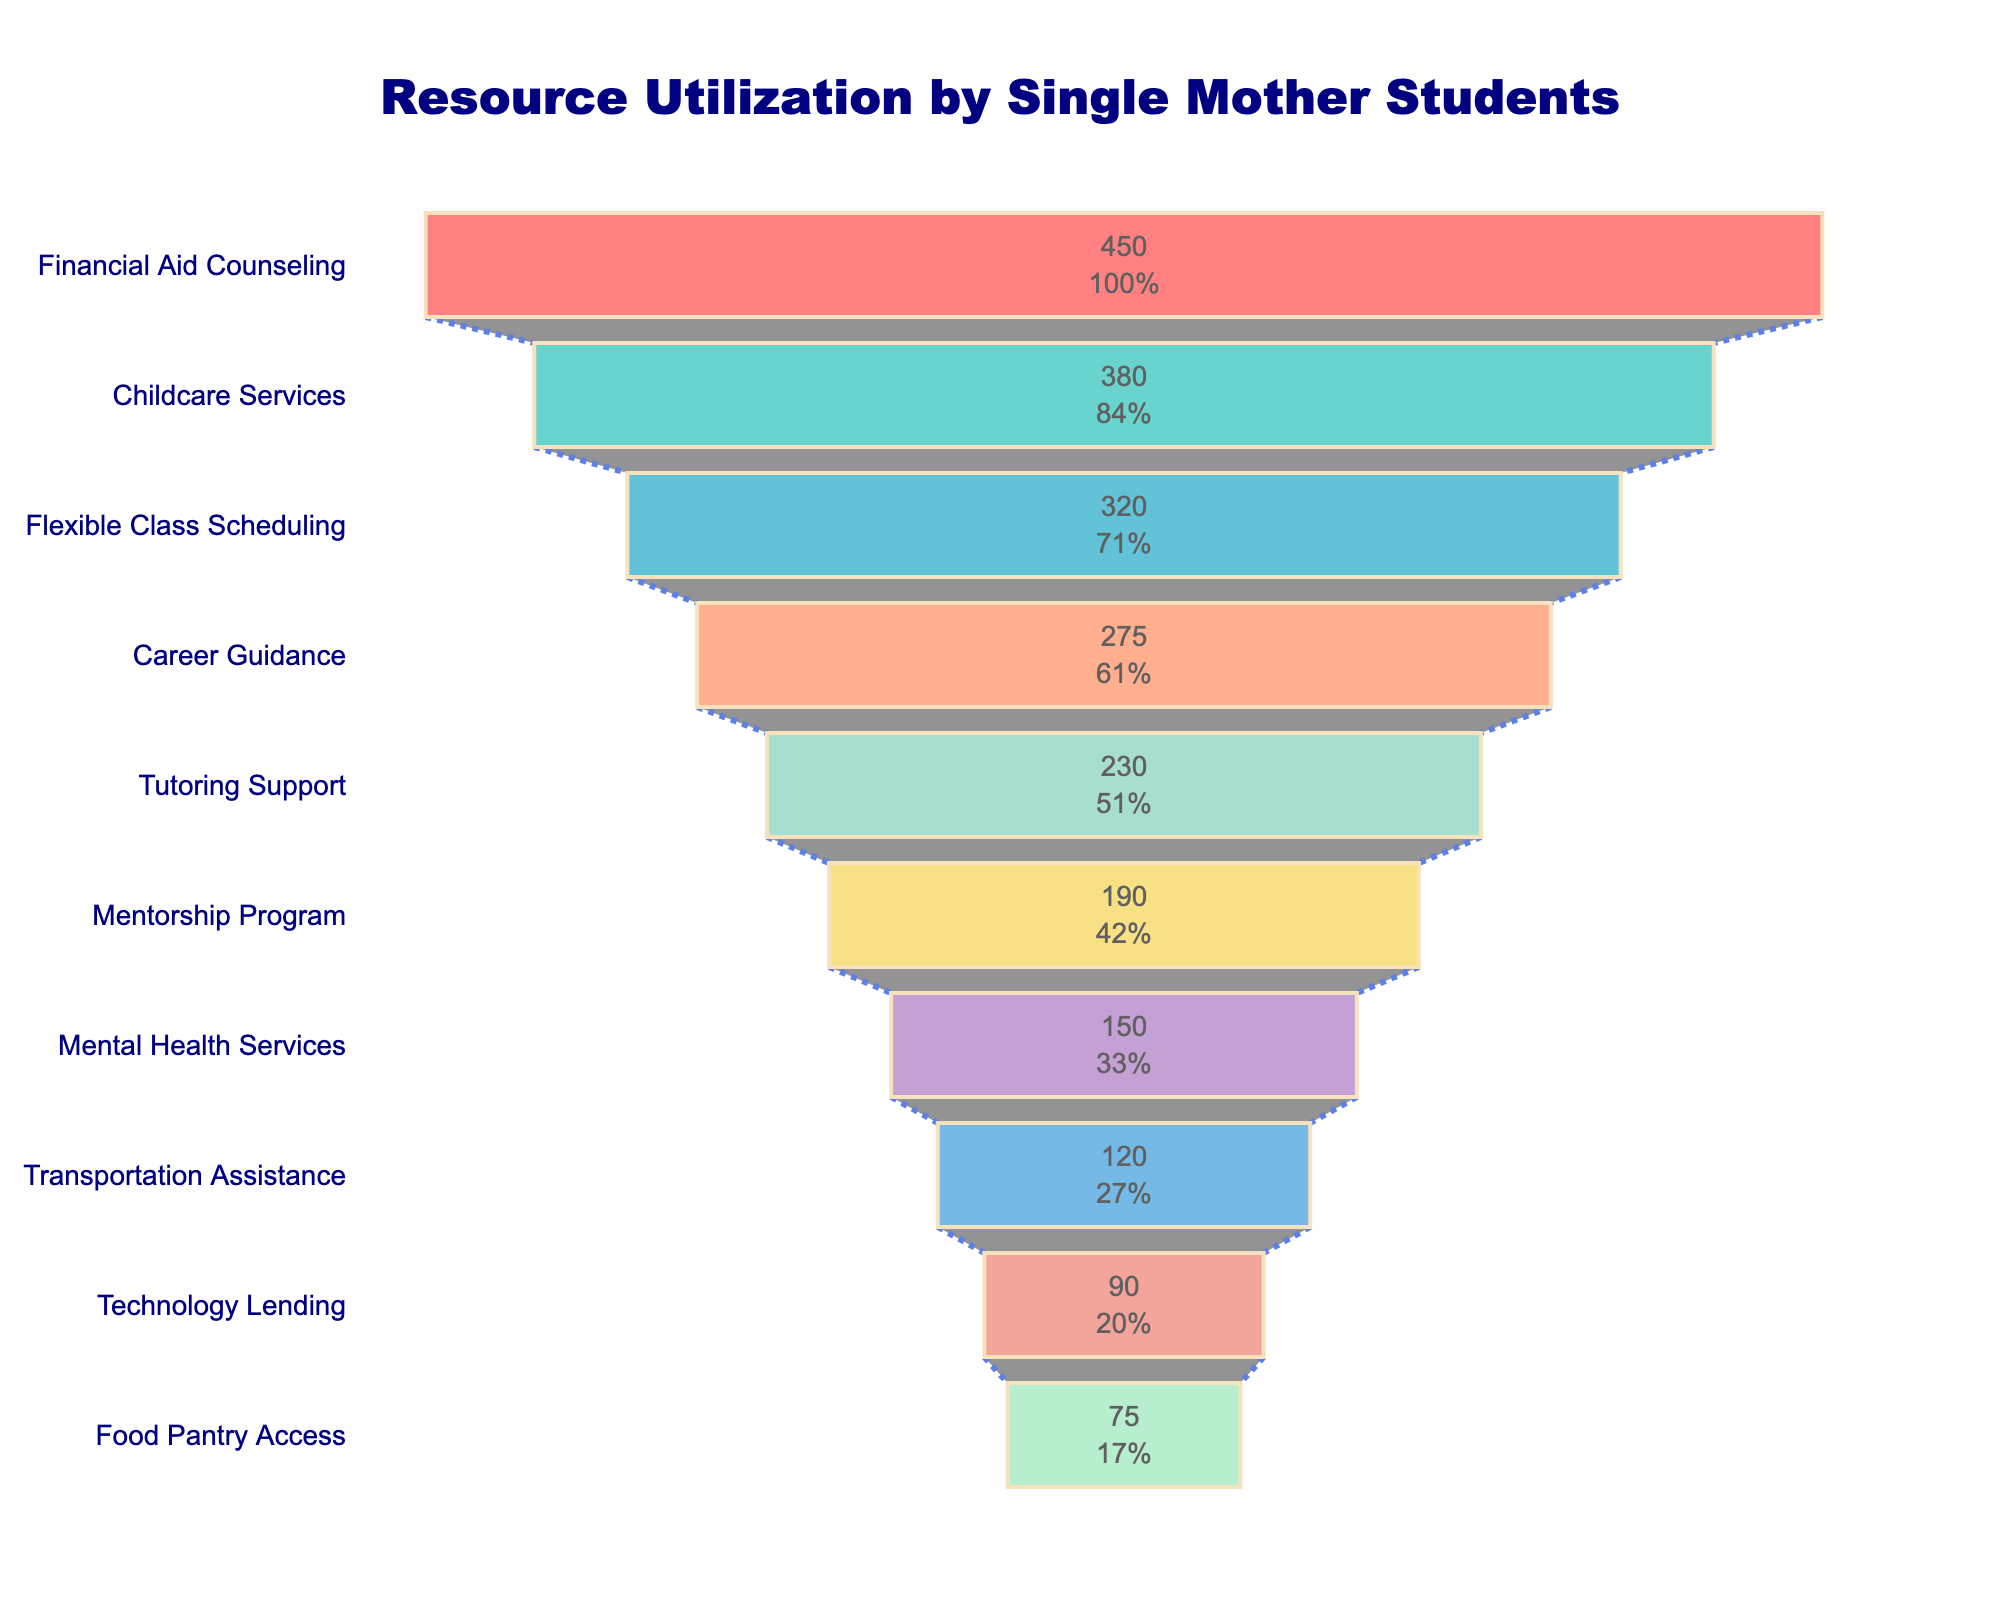What is the title of the figure? The title is usually located at the top of the funnel chart, which describes the content of the figure. The text should be bold and prominent.
Answer: "Resource Utilization by Single Mother Students" What service has the highest number of users? To find this, look at the largest segment at the top of the funnel chart which represents the service with the highest utilization.
Answer: Financial Aid Counseling How many users access Childcare Services? Locate Childcare Services on the funnel chart and refer to the value displayed within or next to it.
Answer: 380 What is the combined number of users for Career Guidance and Mentorship Program? Locate both Career Guidance and Mentorship Program on the chart, note their values, and sum them up: 275 (Career Guidance) + 190 (Mentorship Program).
Answer: 465 Which service has less users: Technology Lending or Food Pantry Access? Compare the segments for Technology Lending and Food Pantry Access on the funnel chart and note which has the smaller value.
Answer: Food Pantry Access How many more users access Flexible Class Scheduling than Transportation Assistance? Locate Flexible Class Scheduling and Transportation Assistance on the chart and subtract the value of Transportation Assistance from Flexible Class Scheduling: 320 (Flexible Class Scheduling) - 120 (Transportation Assistance).
Answer: 200 What percentage of the initial number of users access Tutoring Support? Find Tutoring Support on the chart and refer to the percentage value displayed next to or inside its segment.
Answer: 51.11% What are the colors used in the funnel chart? Examine the colors visually represented on each segment of the funnel, identifying the variety of colors used.
Answer: Red, teal, blue, orange, mint green, yellow, purple, light blue, salmon, light green Which resource is positioned directly below Career Guidance? Find Career Guidance in the funnel chart and look at the next segment below it to identify the following resource.
Answer: Tutoring Support What is the total number of users for all services combined? Add the numbers of users for all the services: 450 + 380 + 320 + 275 + 230 + 190 + 150 + 120 + 90 + 75.
Answer: 2280 